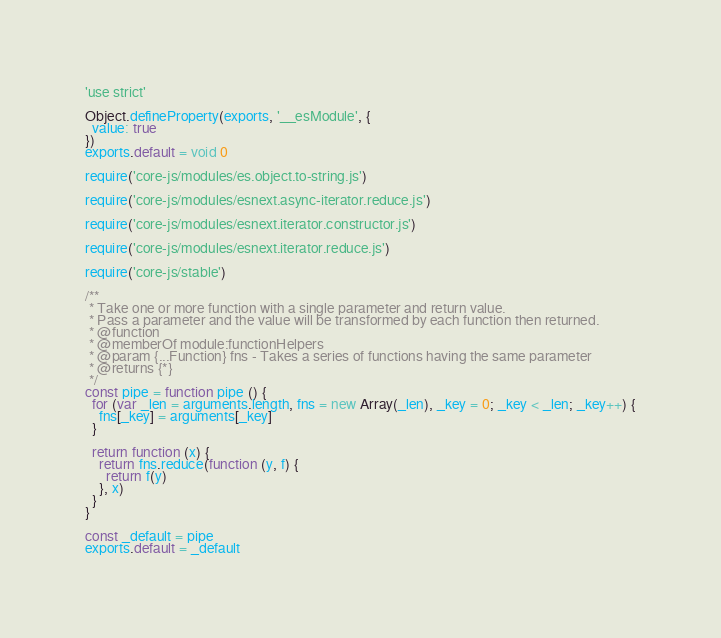<code> <loc_0><loc_0><loc_500><loc_500><_JavaScript_>'use strict'

Object.defineProperty(exports, '__esModule', {
  value: true
})
exports.default = void 0

require('core-js/modules/es.object.to-string.js')

require('core-js/modules/esnext.async-iterator.reduce.js')

require('core-js/modules/esnext.iterator.constructor.js')

require('core-js/modules/esnext.iterator.reduce.js')

require('core-js/stable')

/**
 * Take one or more function with a single parameter and return value.
 * Pass a parameter and the value will be transformed by each function then returned.
 * @function
 * @memberOf module:functionHelpers
 * @param {...Function} fns - Takes a series of functions having the same parameter
 * @returns {*}
 */
const pipe = function pipe () {
  for (var _len = arguments.length, fns = new Array(_len), _key = 0; _key < _len; _key++) {
    fns[_key] = arguments[_key]
  }

  return function (x) {
    return fns.reduce(function (y, f) {
      return f(y)
    }, x)
  }
}

const _default = pipe
exports.default = _default
</code> 